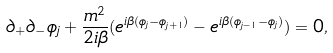<formula> <loc_0><loc_0><loc_500><loc_500>\partial _ { + } \partial _ { - } \phi _ { j } + \frac { m ^ { 2 } } { 2 i \beta } ( e ^ { i \beta ( \phi _ { j } - \phi _ { j + 1 } ) } - e ^ { i \beta ( \phi _ { j - 1 } - \phi _ { j } ) } ) = 0 ,</formula> 